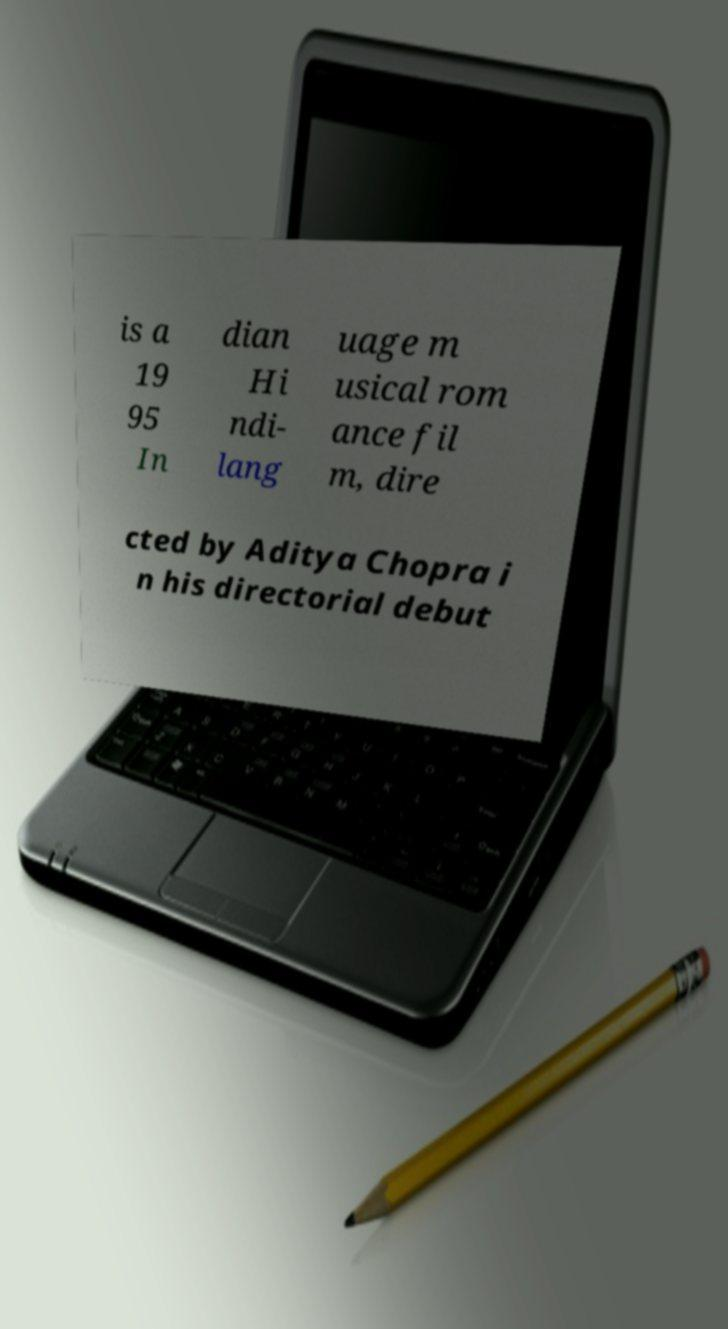Could you assist in decoding the text presented in this image and type it out clearly? is a 19 95 In dian Hi ndi- lang uage m usical rom ance fil m, dire cted by Aditya Chopra i n his directorial debut 